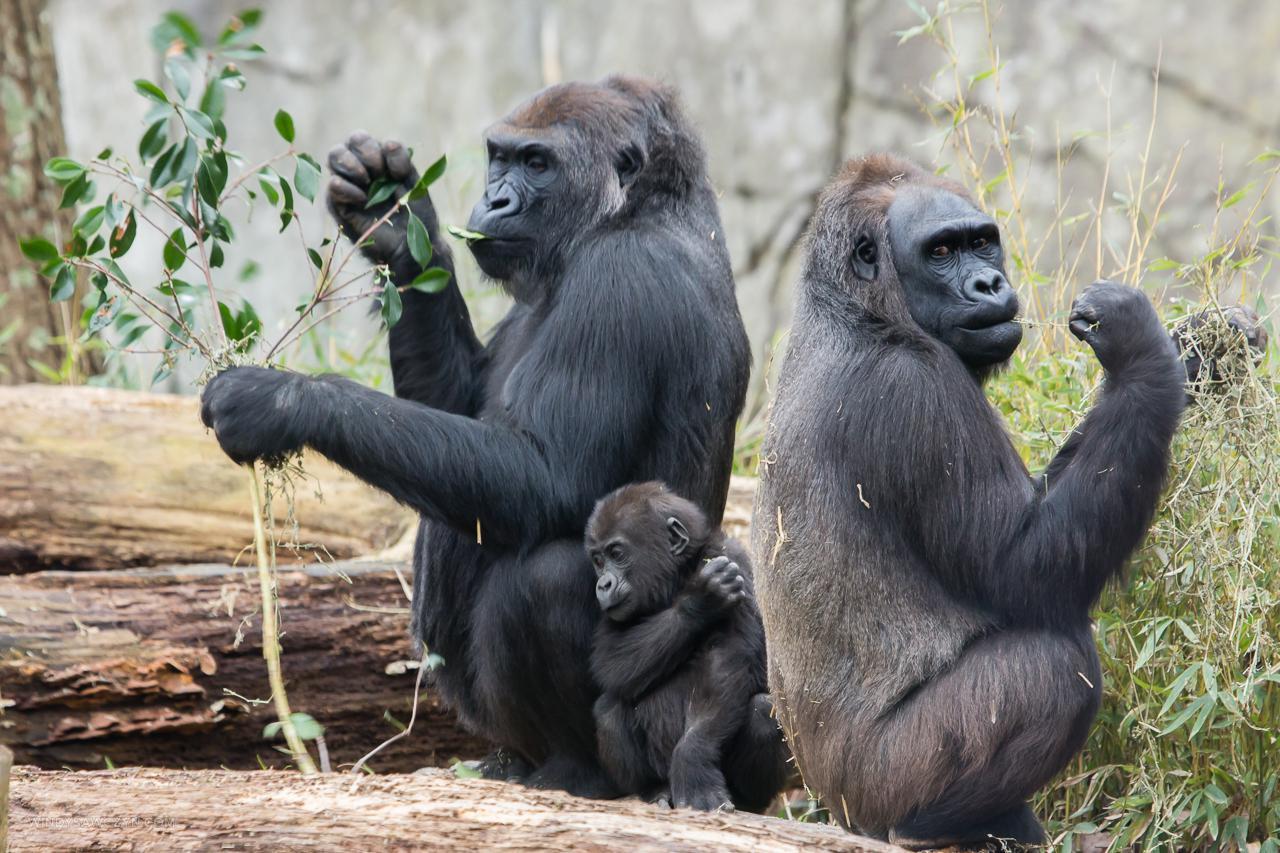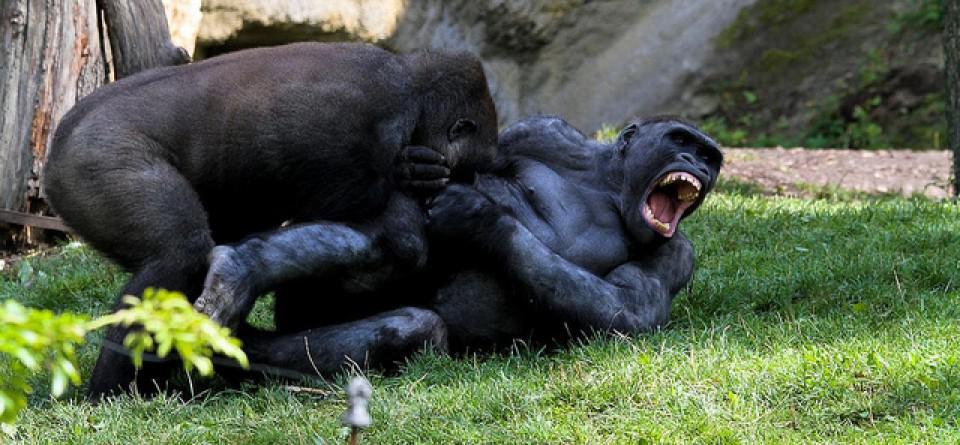The first image is the image on the left, the second image is the image on the right. Assess this claim about the two images: "One of the images shows exactly one adult gorilla and one baby gorilla in close proximity.". Correct or not? Answer yes or no. No. The first image is the image on the left, the second image is the image on the right. Considering the images on both sides, is "An image shows a baby gorilla on the right and one adult gorilla, which is sitting on the left." valid? Answer yes or no. No. 